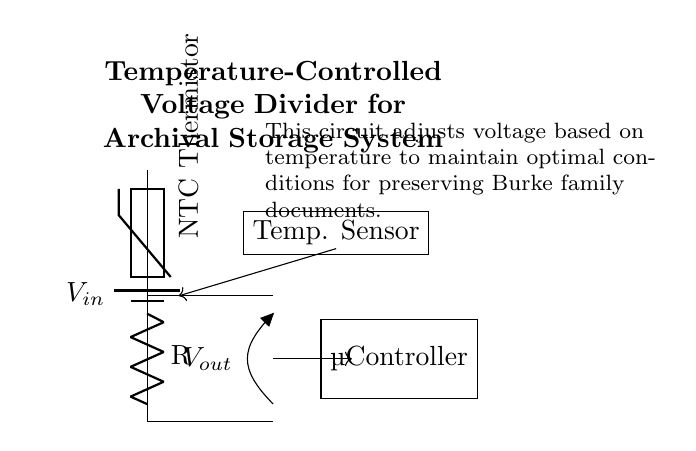What is the type of thermistor used in this circuit? The circuit diagram specifies that an NTC (Negative Temperature Coefficient) thermistor is being used, which is indicated by the label in the diagram.
Answer: NTC Thermistor What is the function of the microcontroller in this circuit? The microcontroller processes the voltage output from the voltage divider to maintain optimal preservation conditions by monitoring and adjusting temperature, as inferred from its role in circuit management and data acquisition.
Answer: Temperature control What is the output voltage indication in the diagram? The diagram shows a label indicating the output voltage as Vout, meaning it is where the voltage is obtained after the voltage division occurs.
Answer: Vout How many main components are there in the voltage divider? The main components in this voltage divider consist of the NTC thermistor and a fixed resistor, hence there are two primary components responsible for the voltage division.
Answer: Two What does the output voltage represent in relation to temperature changes? The output voltage is dependent on the temperature because the NTC thermistor's resistance decreases as the temperature increases, affecting Vout based on the voltage divider principle.
Answer: Temperature-dependent voltage What is the role of the temperature sensor in this circuit? The temperature sensor provides real-time measurements of the environmental temperature to the microcontroller, creating feedback for adjustments in the preservation process.
Answer: Real-time measurement How does changing temperature affect the resistance of the NTC thermistor? As the temperature increases, the resistance of the NTC thermistor decreases, leading to a corresponding change in output voltage according to Ohm's law and the characteristics of voltage dividers.
Answer: Decreases 